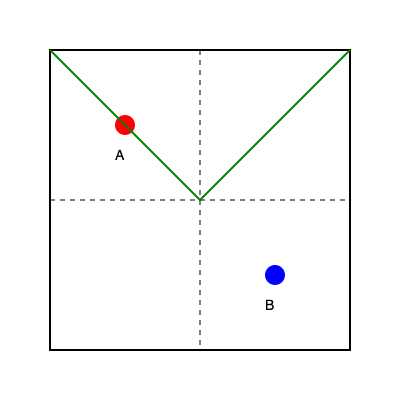In the enchanted map before you, young one, imagine folding it along the dashed lines so that point A touches point B. Where would the treasure marked by the green line be located after the fold? Let's unfold this magical map step by step, my dear:

1. First, observe that the map is divided into four equal squares by the dashed lines.
2. Point A is in the top-left square, and point B is in the bottom-right square.
3. To make A touch B, we need to fold the map twice:
   a) First, fold along the vertical dashed line, bringing the left half over the right half.
   b) Then, fold along the horizontal dashed line, bringing the top half down to the bottom half.
4. The green line, representing the path to the treasure, forms a triangle:
   a) It starts at the top-left corner, passes through the center, and ends at the top-right corner.
5. After the first fold (vertical):
   a) The left half of the green line will overlap with the right half.
6. After the second fold (horizontal):
   a) The top half of the folded line will overlap with the bottom half.
7. The result is that all parts of the green line will converge at one point.
8. This point is where the dashed lines intersect - the center of the original map.

Therefore, after folding, the entire green line (representing the treasure's location) will be at the center point of the original map, where the dashed lines intersect.
Answer: Center of the map 